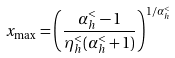Convert formula to latex. <formula><loc_0><loc_0><loc_500><loc_500>x _ { \max } = \left ( \frac { \alpha _ { h } ^ { < } - 1 } { \eta ^ { < } _ { h } ( \alpha _ { h } ^ { < } + 1 ) } \right ) ^ { 1 / \alpha _ { h } ^ { < } }</formula> 